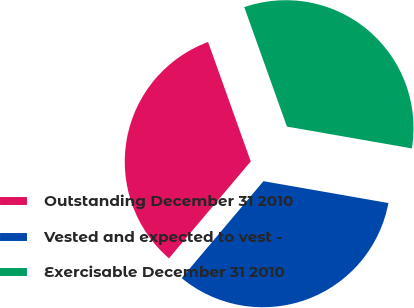Convert chart to OTSL. <chart><loc_0><loc_0><loc_500><loc_500><pie_chart><fcel>Outstanding December 31 2010<fcel>Vested and expected to vest -<fcel>Exercisable December 31 2010<nl><fcel>33.38%<fcel>33.4%<fcel>33.22%<nl></chart> 